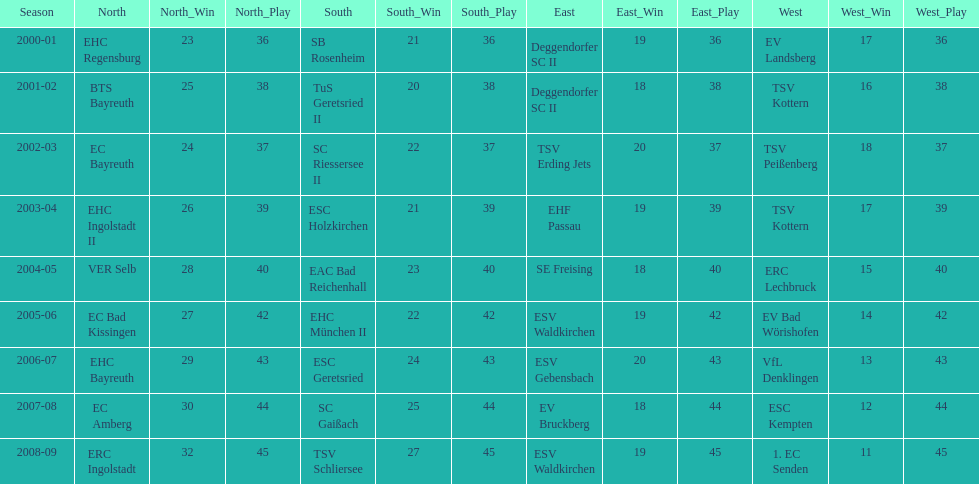Who won the south after esc geretsried did during the 2006-07 season? SC Gaißach. 